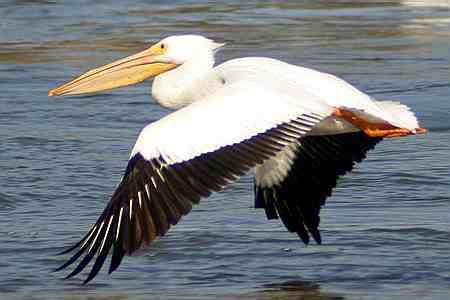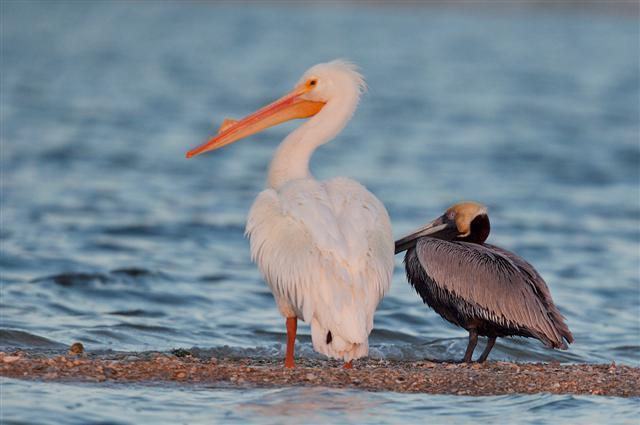The first image is the image on the left, the second image is the image on the right. Assess this claim about the two images: "At least two pelicans are present in one of the images.". Correct or not? Answer yes or no. Yes. The first image is the image on the left, the second image is the image on the right. For the images shown, is this caption "The bird in the image on the right is flying" true? Answer yes or no. No. 